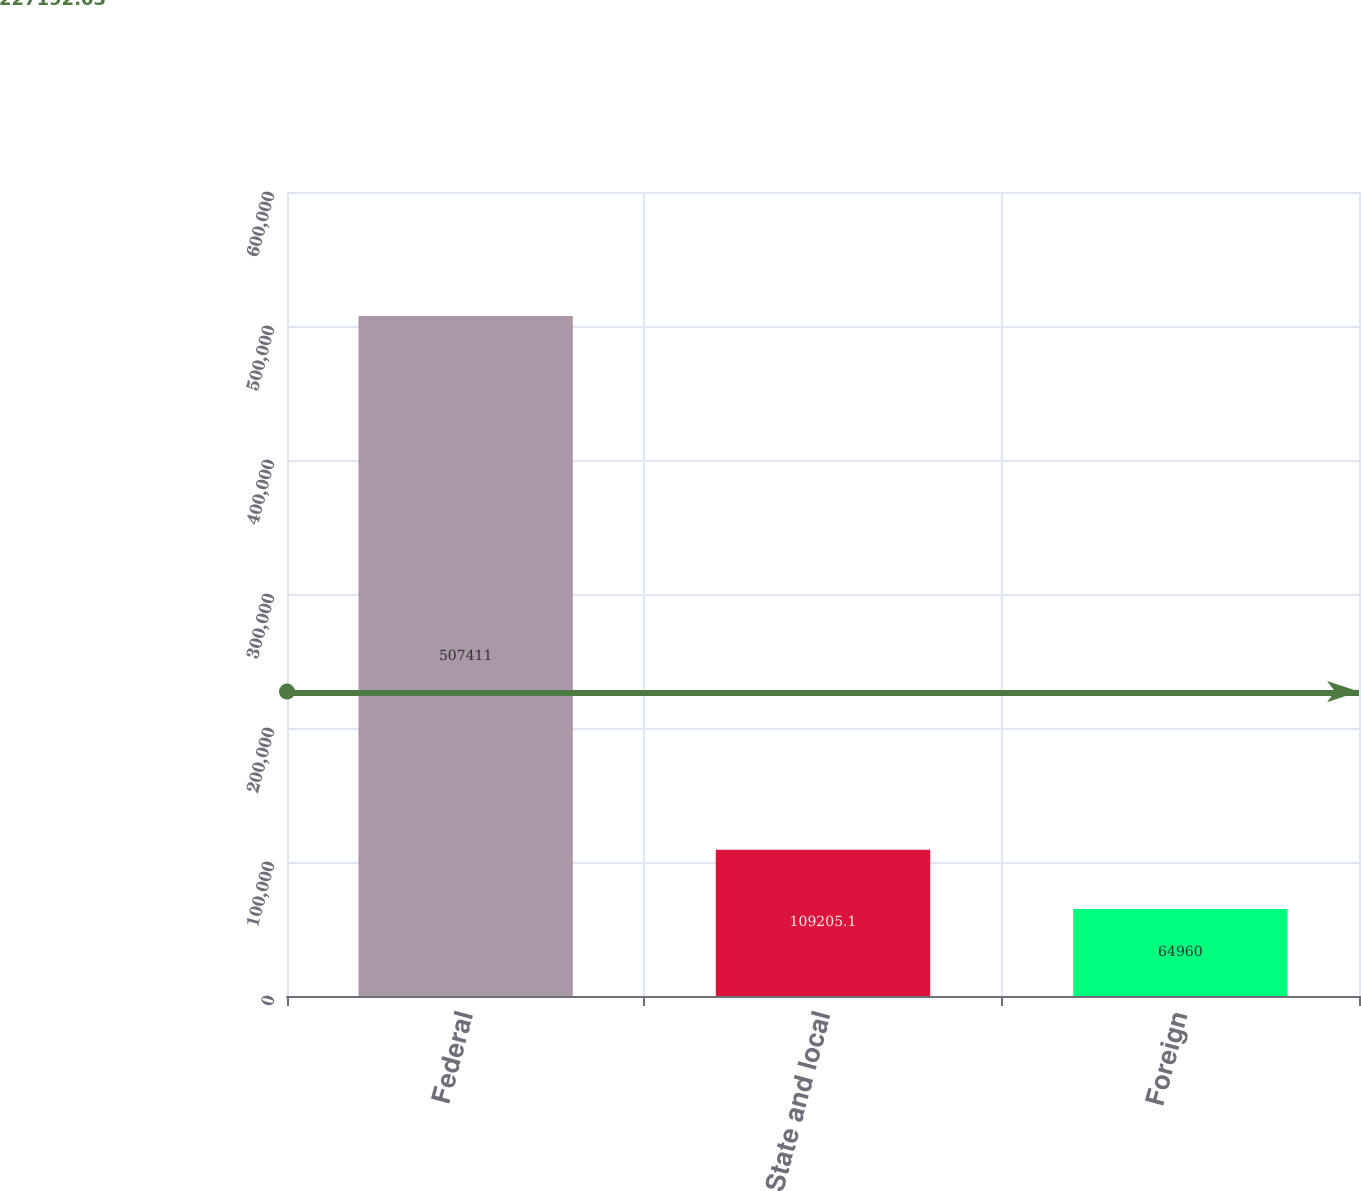Convert chart. <chart><loc_0><loc_0><loc_500><loc_500><bar_chart><fcel>Federal<fcel>State and local<fcel>Foreign<nl><fcel>507411<fcel>109205<fcel>64960<nl></chart> 